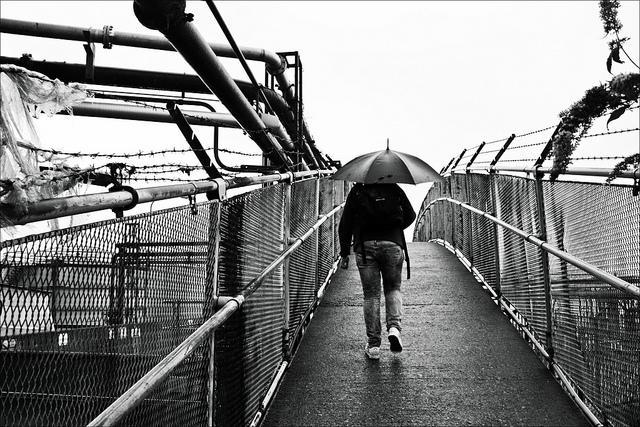Is it raining?
Concise answer only. Yes. Can cars go on this bridge?
Quick response, please. No. Is this a man or woman?
Give a very brief answer. Woman. 